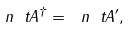Convert formula to latex. <formula><loc_0><loc_0><loc_500><loc_500>\ n { \ t A ^ { \dag } } = \ n { \ t A ^ { \prime } } ,</formula> 